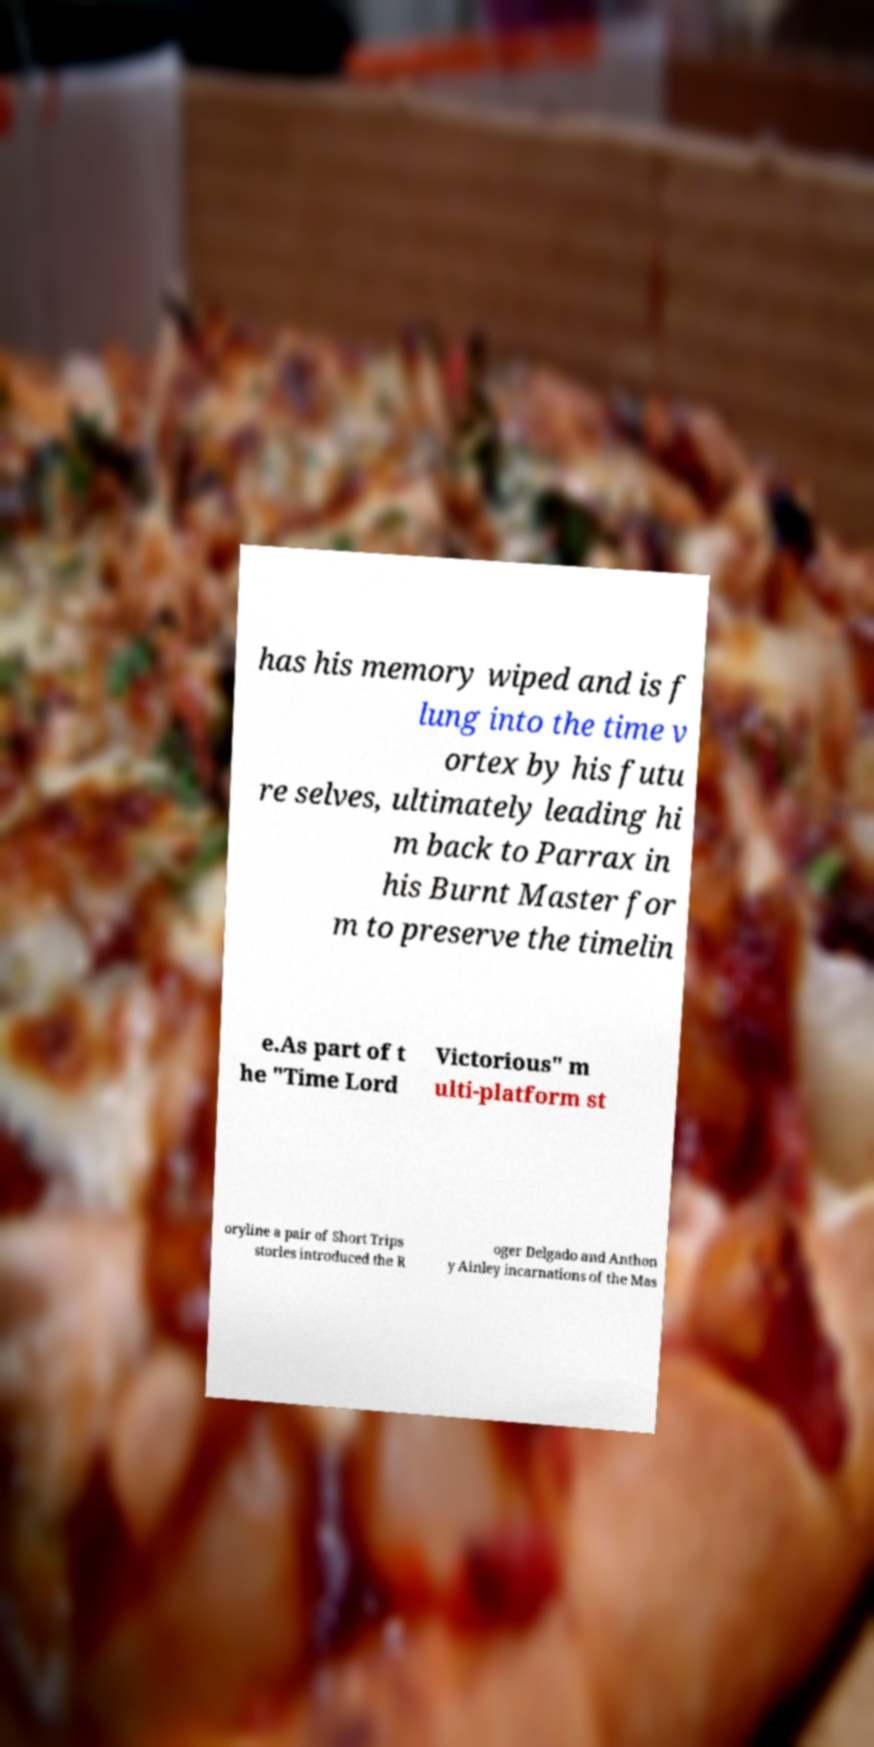What messages or text are displayed in this image? I need them in a readable, typed format. has his memory wiped and is f lung into the time v ortex by his futu re selves, ultimately leading hi m back to Parrax in his Burnt Master for m to preserve the timelin e.As part of t he "Time Lord Victorious" m ulti-platform st oryline a pair of Short Trips stories introduced the R oger Delgado and Anthon y Ainley incarnations of the Mas 